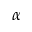Convert formula to latex. <formula><loc_0><loc_0><loc_500><loc_500>\alpha</formula> 